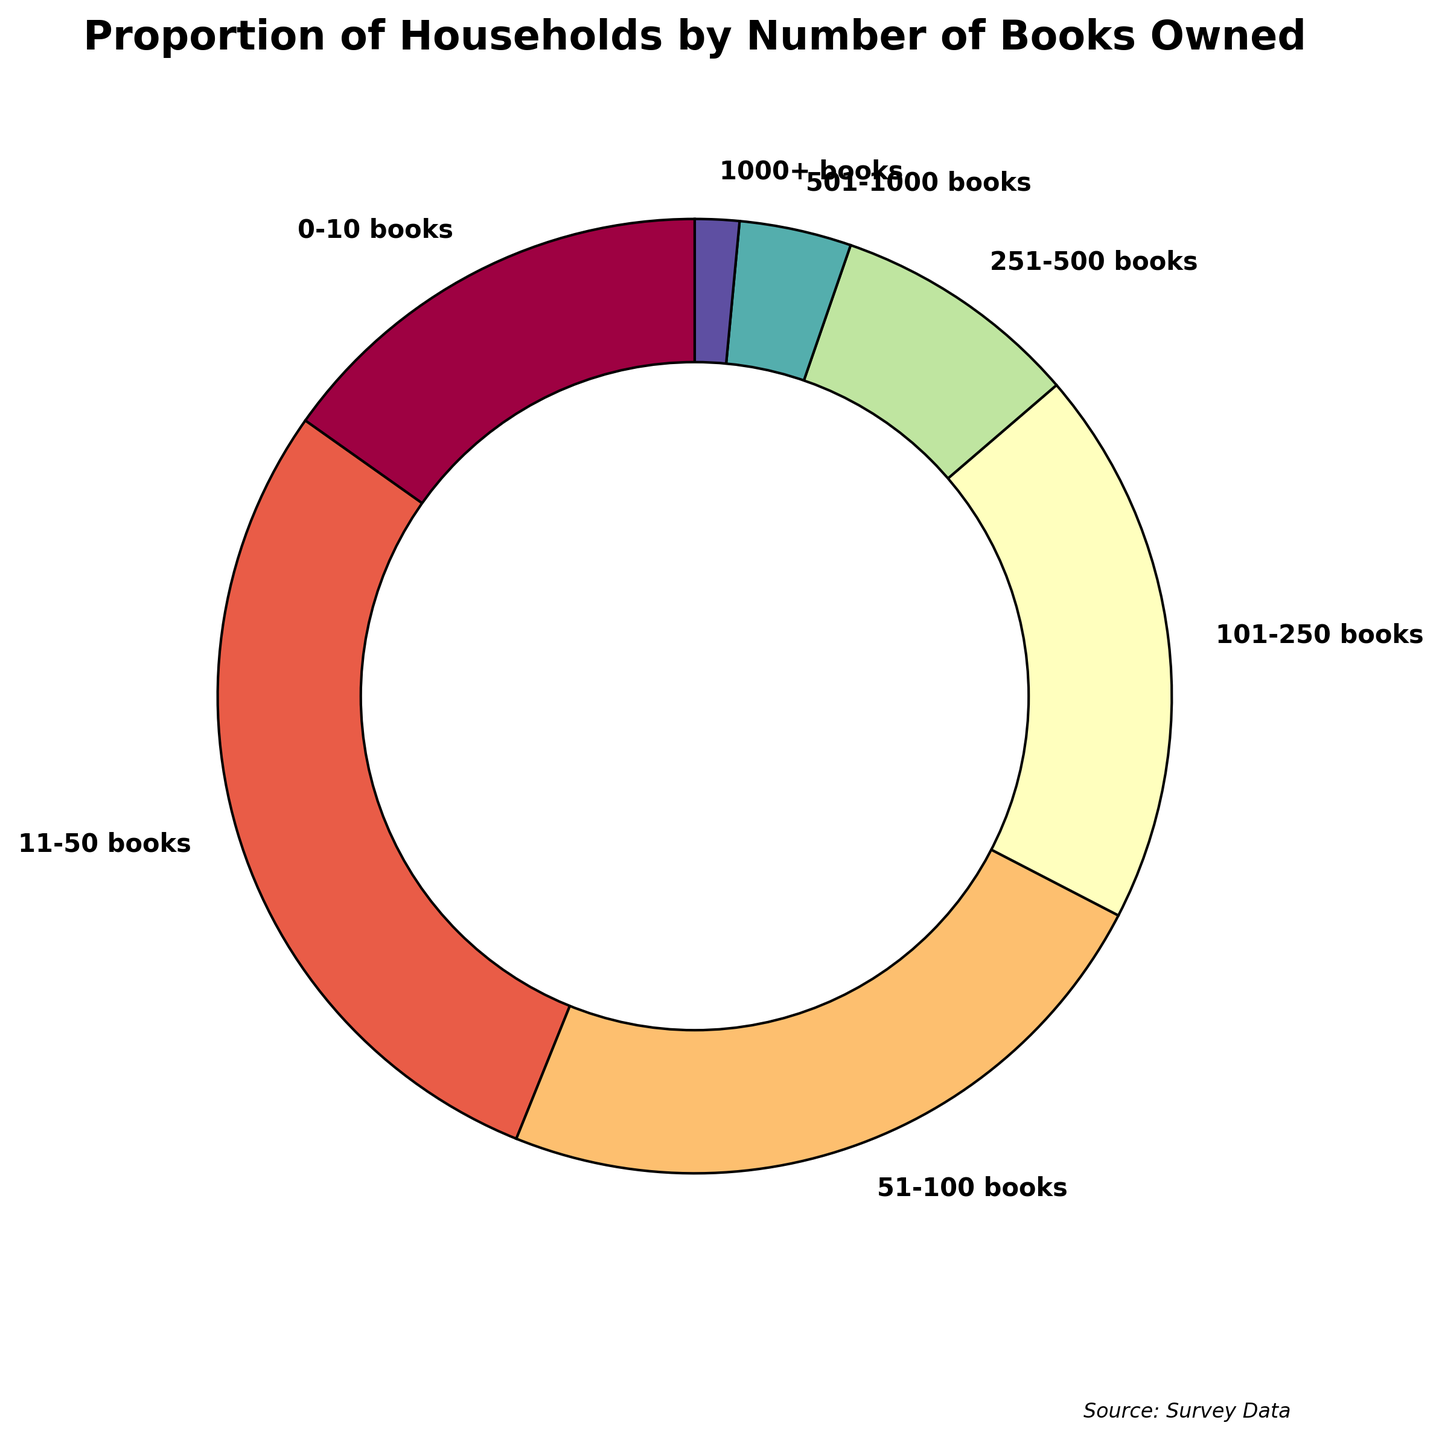Which category has the highest proportion of households? The pie chart shows that the segment labeled "11-50 books" has the largest portion with 28.7%. By visually comparing the sizes, we can see that other segments are smaller.
Answer: 11-50 books Which category has the smallest proportion of households? The smallest segment of the pie chart represents the "1000+ books" category, which is labeled with 1.5%. By comparing it with other segments, it is clearly the smallest.
Answer: 1000+ books What is the combined percentage of households that own 251 or more books? Adding the percentages of the "251-500 books," "501-1000 books," and "1000+ books" categories: 8.4% + 3.8% + 1.5% = 13.7%.
Answer: 13.7% Is the percentage of households with 101-250 books greater than the percentage of those with 51-100 books? The pie chart labels "101-250 books" with 18.9% and "51-100 books" with 23.5%. Since 23.5% is higher than 18.9%, "51-100 books" has the larger percentage.
Answer: No How much larger is the proportion of households with 11-50 books compared to those with 501-1000 books? The segment "11-50 books" has 28.7%, and "501-1000 books" has 3.8%. The difference is 28.7% - 3.8% = 24.9%.
Answer: 24.9% What is the total percentage of households that own fewer than 51 books? Summing the percentages of "0-10 books" (15.2%) and "11-50 books" (28.7%): 15.2% + 28.7% = 43.9%.
Answer: 43.9% Which segment appears in the darkest color on the chart? The pie chart uses a color gradient, with darker colors often assigned to larger categories. The "11-50 books" segment is the largest (28.7%) and is represented in the darkest color.
Answer: 11-50 books How does the proportion of households owning 101-250 books compare to the total proportion of households owning more than 100 books? Households with more than 100 books include "101-250 books," "251-500 books," "501-1000 books," and "1000+ books." Summing their percentages: 18.9% + 8.4% + 3.8% + 1.5% = 32.6%. The "101-250 books" category itself is 18.9%, which is a part of the 32.6%.
Answer: 101-250 books is part of the 32.6% What three segments collectively account for over half of the households? Summing the three largest segments: "11-50 books" (28.7%), "51-100 books" (23.5%), and "0-10 books" (15.2%): 28.7% + 23.5% + 15.2% = 67.4%. These three segments collectively account for over 50%.
Answer: 0-10 books, 11-50 books, 51-100 books 